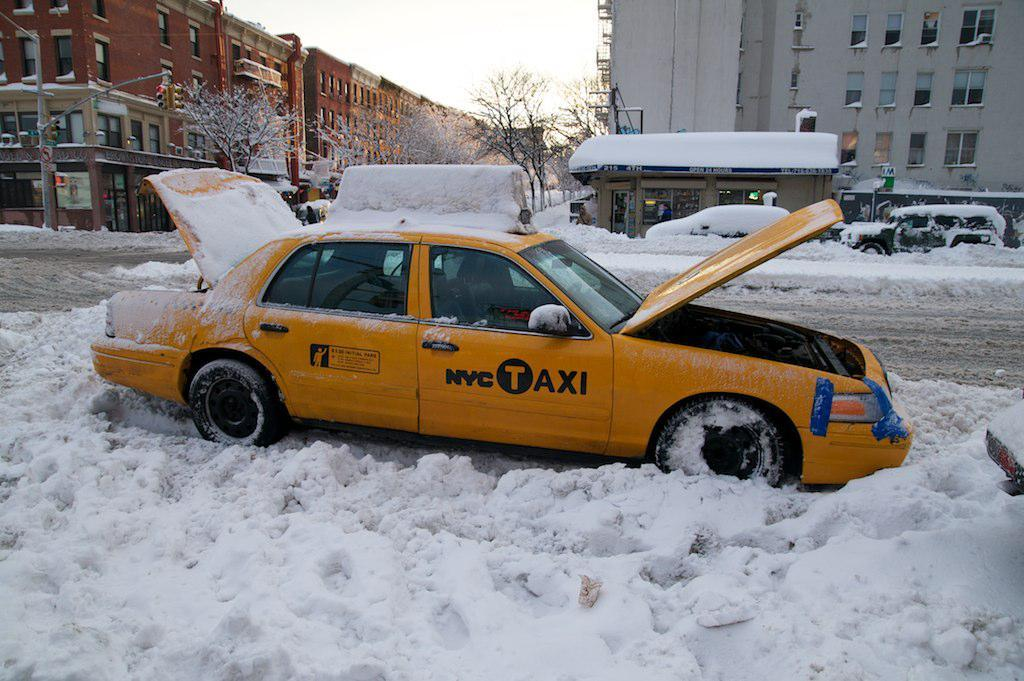<image>
Give a short and clear explanation of the subsequent image. A yellow NYC taxi sits in the snow with the hood and trunk open. 